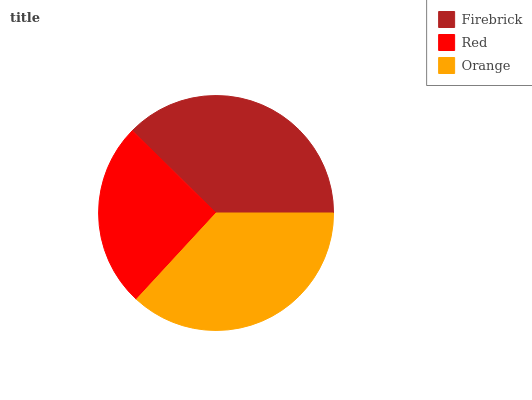Is Red the minimum?
Answer yes or no. Yes. Is Firebrick the maximum?
Answer yes or no. Yes. Is Orange the minimum?
Answer yes or no. No. Is Orange the maximum?
Answer yes or no. No. Is Orange greater than Red?
Answer yes or no. Yes. Is Red less than Orange?
Answer yes or no. Yes. Is Red greater than Orange?
Answer yes or no. No. Is Orange less than Red?
Answer yes or no. No. Is Orange the high median?
Answer yes or no. Yes. Is Orange the low median?
Answer yes or no. Yes. Is Firebrick the high median?
Answer yes or no. No. Is Red the low median?
Answer yes or no. No. 